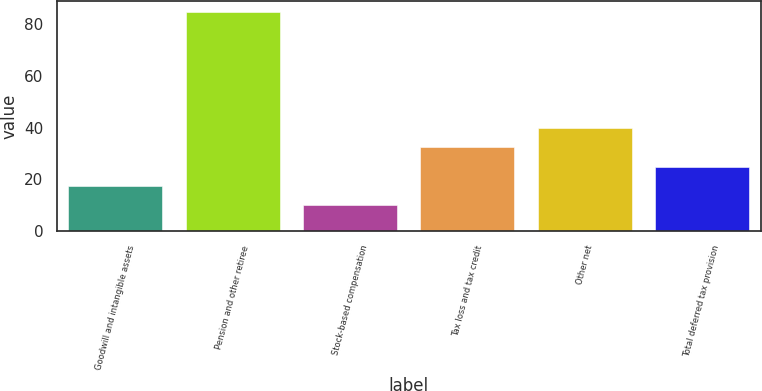Convert chart. <chart><loc_0><loc_0><loc_500><loc_500><bar_chart><fcel>Goodwill and intangible assets<fcel>Pension and other retiree<fcel>Stock-based compensation<fcel>Tax loss and tax credit<fcel>Other net<fcel>Total deferred tax provision<nl><fcel>17.5<fcel>85<fcel>10<fcel>32.5<fcel>40<fcel>25<nl></chart> 